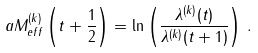<formula> <loc_0><loc_0><loc_500><loc_500>a M _ { e f f } ^ { ( k ) } \left ( t + \frac { 1 } { 2 } \right ) = \ln \left ( \frac { \lambda ^ { ( k ) } ( t ) } { \lambda ^ { ( k ) } ( t + 1 ) } \right ) \, .</formula> 